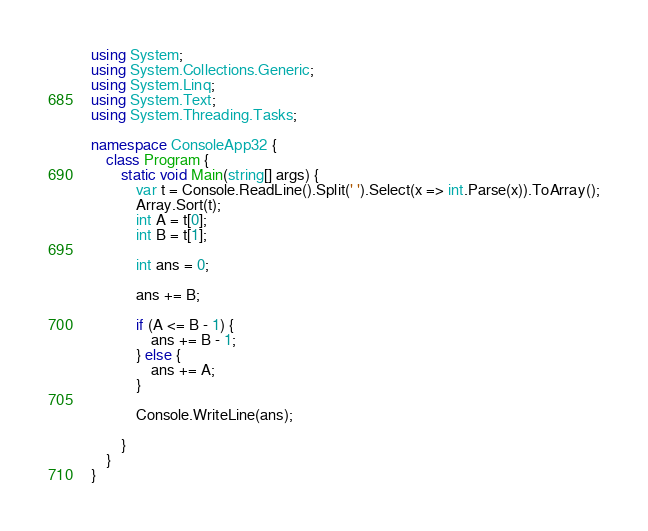Convert code to text. <code><loc_0><loc_0><loc_500><loc_500><_C#_>using System;
using System.Collections.Generic;
using System.Linq;
using System.Text;
using System.Threading.Tasks;

namespace ConsoleApp32 {
    class Program {
        static void Main(string[] args) {
            var t = Console.ReadLine().Split(' ').Select(x => int.Parse(x)).ToArray();
            Array.Sort(t);
            int A = t[0];
            int B = t[1];

            int ans = 0;

            ans += B;

            if (A <= B - 1) {
                ans += B - 1;
            } else {
                ans += A;
            }

            Console.WriteLine(ans);

        }
    }
}
</code> 